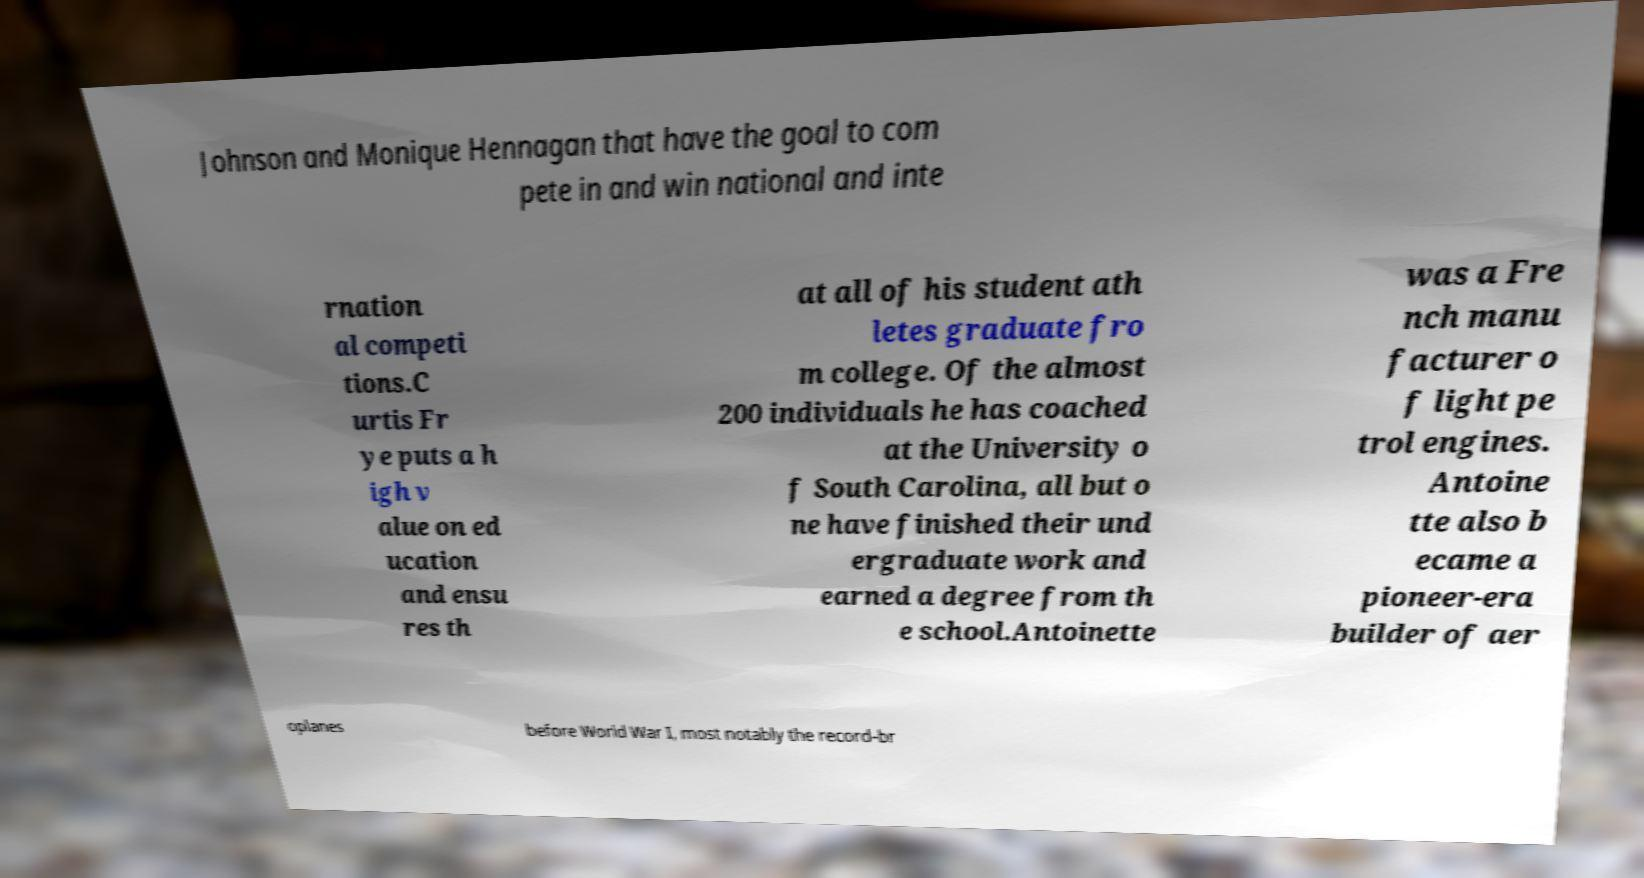For documentation purposes, I need the text within this image transcribed. Could you provide that? Johnson and Monique Hennagan that have the goal to com pete in and win national and inte rnation al competi tions.C urtis Fr ye puts a h igh v alue on ed ucation and ensu res th at all of his student ath letes graduate fro m college. Of the almost 200 individuals he has coached at the University o f South Carolina, all but o ne have finished their und ergraduate work and earned a degree from th e school.Antoinette was a Fre nch manu facturer o f light pe trol engines. Antoine tte also b ecame a pioneer-era builder of aer oplanes before World War I, most notably the record-br 